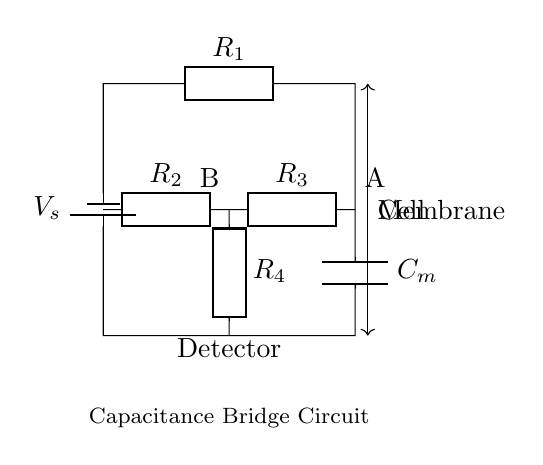What is the voltage source in this circuit? The voltage source is labeled as V_s, which indicates the supply voltage for the circuit.
Answer: V_s What is the capacitance being measured? The capacitance being measured is represented by the component labeled as C_m in the circuit diagram.
Answer: C_m How many resistors are present in this circuit? There are four resistors labeled as R_1, R_2, R_3, and R_4, indicating that the circuit contains four resistors in total.
Answer: Four What is the role of the detector in this circuit? The detector, indicated in the circuit, is used to measure the imbalance in the bridge caused by the capacitance of the cell membrane.
Answer: Measure imbalance What is the configuration type of this bridge circuit? The configuration of this circuit is a capacitance bridge, designed specifically for measuring capacitance, particularly of biological membranes.
Answer: Capacitance bridge If resistance R_1 is greater than R_3, what can be inferred about C_m? If R_1 is greater than R_3, it indicates that the bridge is unbalanced, meaning the measured capacitance C_m must also be greater to restore balance.
Answer: C_m is greater What does the label "Cell" in the circuit indicate? The label "Cell" specifies the part of the circuit that represents the biological cell membrane whose capacitance is being evaluated.
Answer: Biological cell 